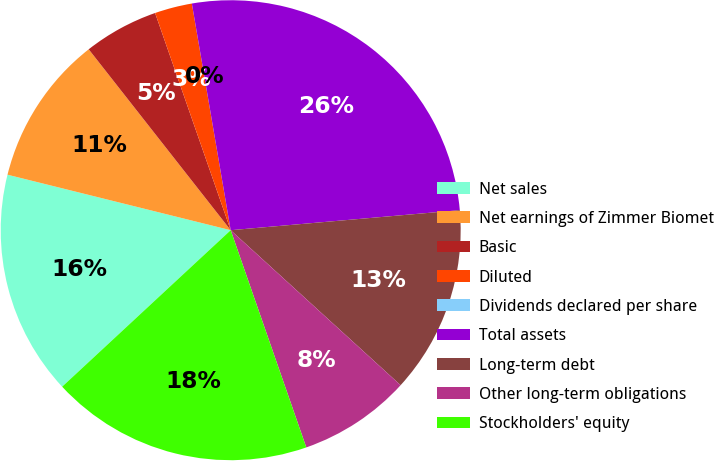<chart> <loc_0><loc_0><loc_500><loc_500><pie_chart><fcel>Net sales<fcel>Net earnings of Zimmer Biomet<fcel>Basic<fcel>Diluted<fcel>Dividends declared per share<fcel>Total assets<fcel>Long-term debt<fcel>Other long-term obligations<fcel>Stockholders' equity<nl><fcel>15.79%<fcel>10.53%<fcel>5.26%<fcel>2.63%<fcel>0.0%<fcel>26.31%<fcel>13.16%<fcel>7.9%<fcel>18.42%<nl></chart> 